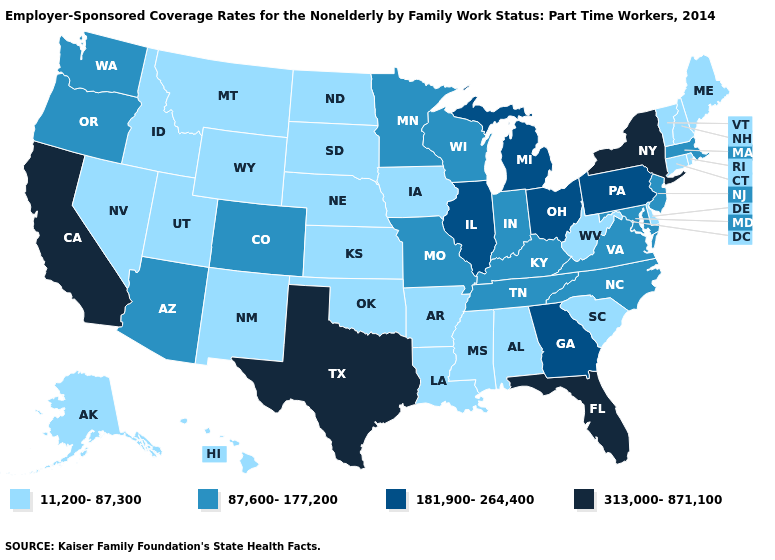Does Massachusetts have a lower value than Vermont?
Keep it brief. No. Which states have the lowest value in the Northeast?
Keep it brief. Connecticut, Maine, New Hampshire, Rhode Island, Vermont. Name the states that have a value in the range 11,200-87,300?
Concise answer only. Alabama, Alaska, Arkansas, Connecticut, Delaware, Hawaii, Idaho, Iowa, Kansas, Louisiana, Maine, Mississippi, Montana, Nebraska, Nevada, New Hampshire, New Mexico, North Dakota, Oklahoma, Rhode Island, South Carolina, South Dakota, Utah, Vermont, West Virginia, Wyoming. What is the highest value in the USA?
Be succinct. 313,000-871,100. Does the map have missing data?
Concise answer only. No. Among the states that border Mississippi , which have the lowest value?
Write a very short answer. Alabama, Arkansas, Louisiana. How many symbols are there in the legend?
Quick response, please. 4. What is the value of Idaho?
Answer briefly. 11,200-87,300. Among the states that border Ohio , does Pennsylvania have the lowest value?
Quick response, please. No. Among the states that border Nevada , which have the lowest value?
Short answer required. Idaho, Utah. Name the states that have a value in the range 313,000-871,100?
Write a very short answer. California, Florida, New York, Texas. Among the states that border Iowa , which have the highest value?
Concise answer only. Illinois. Which states have the lowest value in the MidWest?
Give a very brief answer. Iowa, Kansas, Nebraska, North Dakota, South Dakota. How many symbols are there in the legend?
Concise answer only. 4. Does Oregon have a higher value than Minnesota?
Write a very short answer. No. 